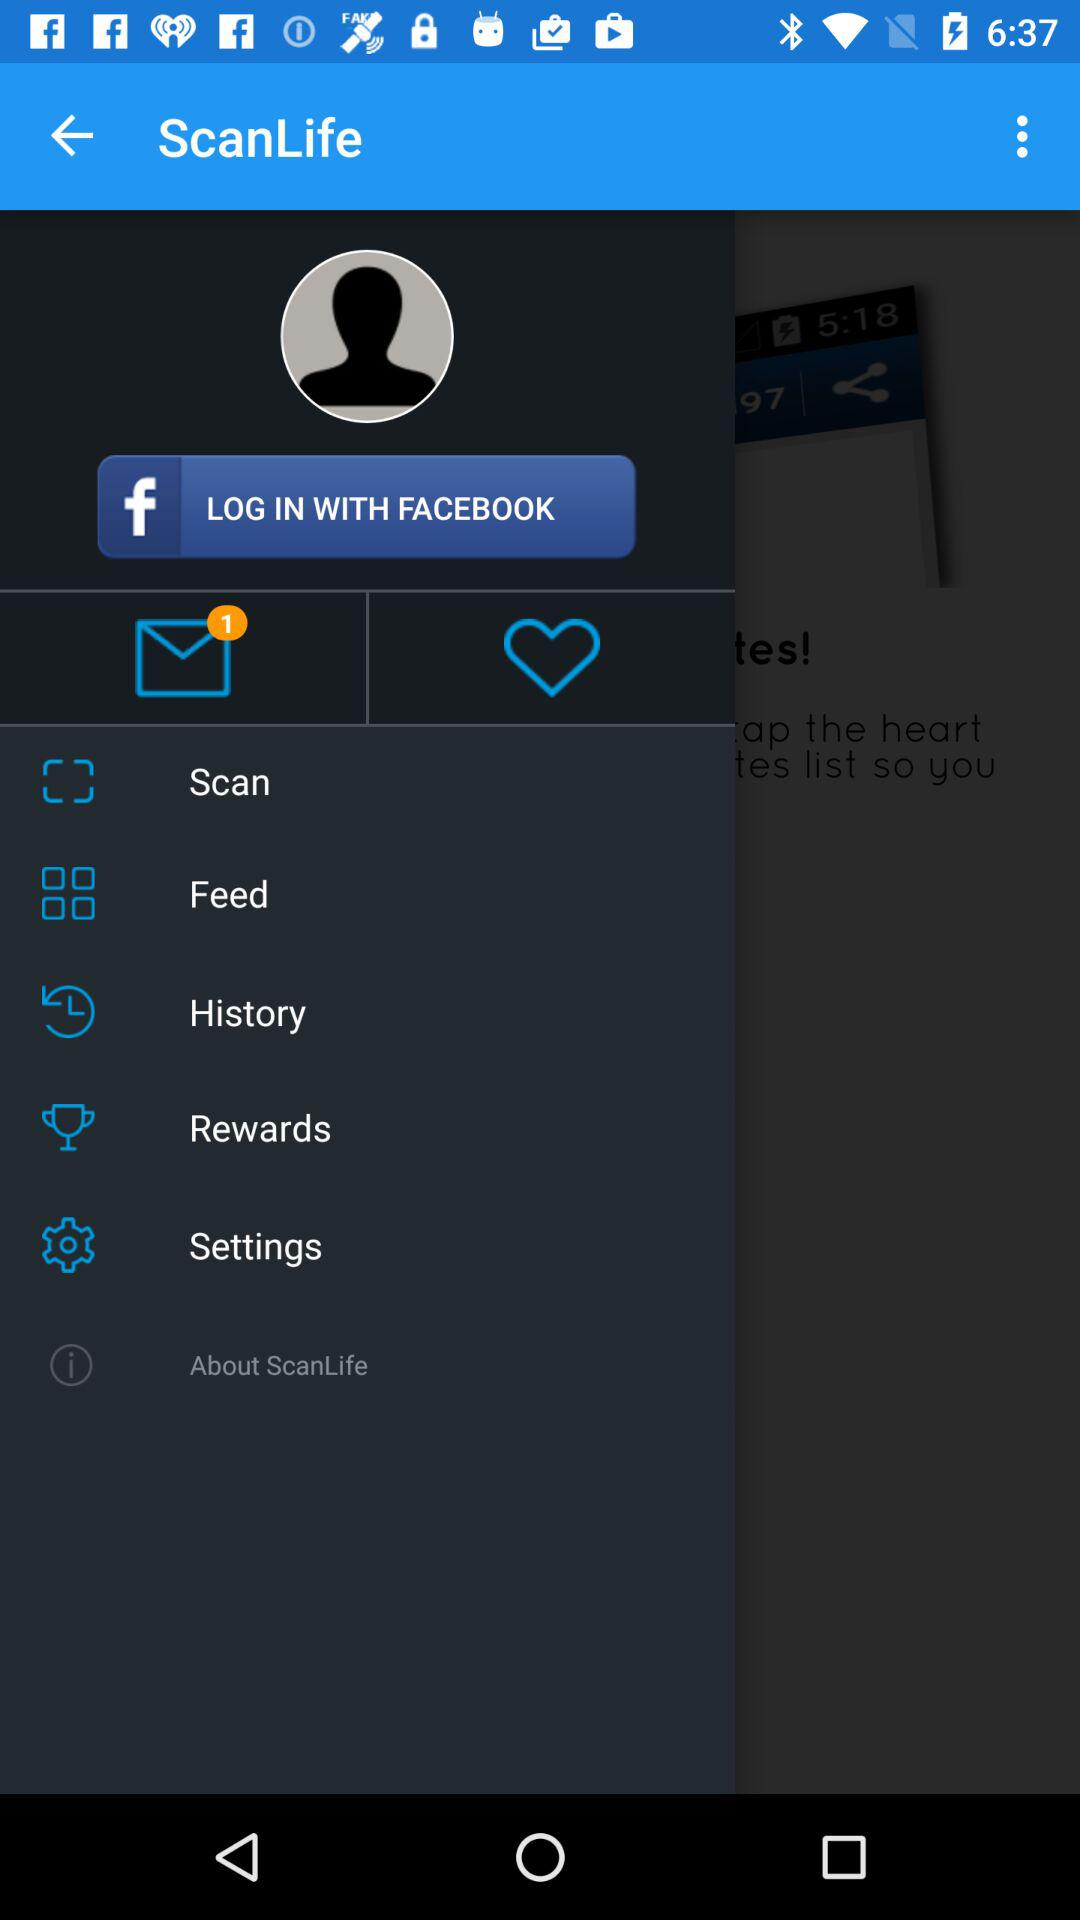How many messages are unread? There is 1 unread message. 